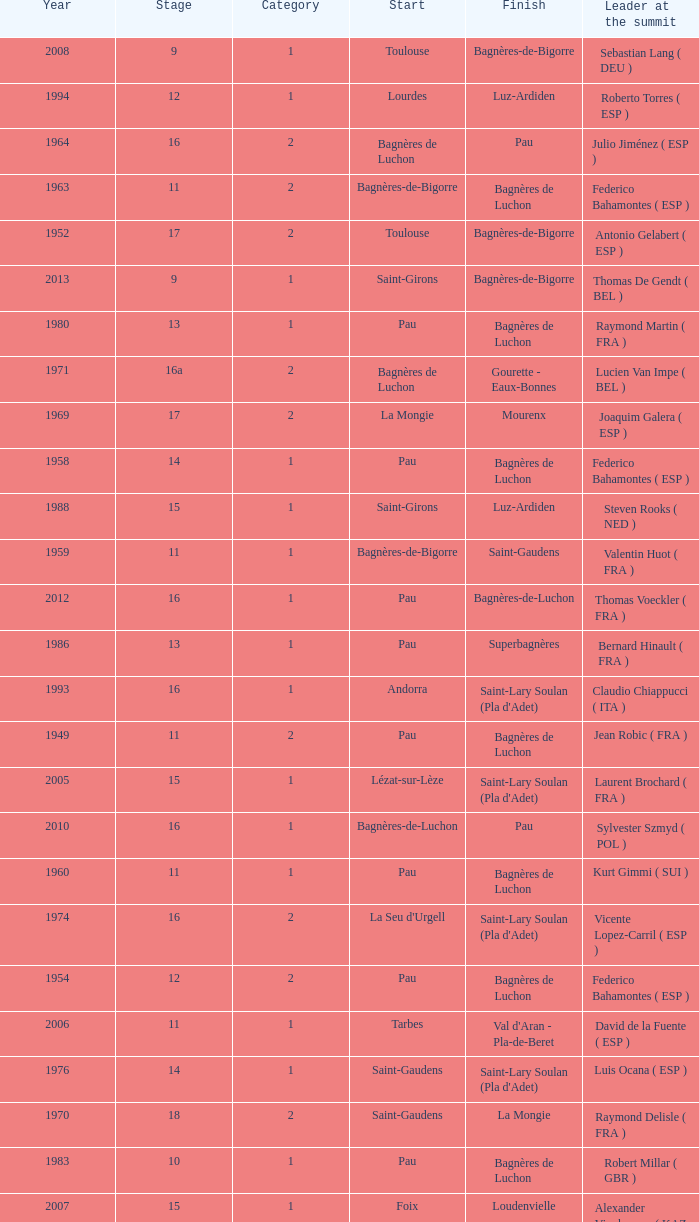What stage has a start of saint-girons in 1988? 15.0. I'm looking to parse the entire table for insights. Could you assist me with that? {'header': ['Year', 'Stage', 'Category', 'Start', 'Finish', 'Leader at the summit'], 'rows': [['2008', '9', '1', 'Toulouse', 'Bagnères-de-Bigorre', 'Sebastian Lang ( DEU )'], ['1994', '12', '1', 'Lourdes', 'Luz-Ardiden', 'Roberto Torres ( ESP )'], ['1964', '16', '2', 'Bagnères de Luchon', 'Pau', 'Julio Jiménez ( ESP )'], ['1963', '11', '2', 'Bagnères-de-Bigorre', 'Bagnères de Luchon', 'Federico Bahamontes ( ESP )'], ['1952', '17', '2', 'Toulouse', 'Bagnères-de-Bigorre', 'Antonio Gelabert ( ESP )'], ['2013', '9', '1', 'Saint-Girons', 'Bagnères-de-Bigorre', 'Thomas De Gendt ( BEL )'], ['1980', '13', '1', 'Pau', 'Bagnères de Luchon', 'Raymond Martin ( FRA )'], ['1971', '16a', '2', 'Bagnères de Luchon', 'Gourette - Eaux-Bonnes', 'Lucien Van Impe ( BEL )'], ['1969', '17', '2', 'La Mongie', 'Mourenx', 'Joaquim Galera ( ESP )'], ['1958', '14', '1', 'Pau', 'Bagnères de Luchon', 'Federico Bahamontes ( ESP )'], ['1988', '15', '1', 'Saint-Girons', 'Luz-Ardiden', 'Steven Rooks ( NED )'], ['1959', '11', '1', 'Bagnères-de-Bigorre', 'Saint-Gaudens', 'Valentin Huot ( FRA )'], ['2012', '16', '1', 'Pau', 'Bagnères-de-Luchon', 'Thomas Voeckler ( FRA )'], ['1986', '13', '1', 'Pau', 'Superbagnères', 'Bernard Hinault ( FRA )'], ['1993', '16', '1', 'Andorra', "Saint-Lary Soulan (Pla d'Adet)", 'Claudio Chiappucci ( ITA )'], ['1949', '11', '2', 'Pau', 'Bagnères de Luchon', 'Jean Robic ( FRA )'], ['2005', '15', '1', 'Lézat-sur-Lèze', "Saint-Lary Soulan (Pla d'Adet)", 'Laurent Brochard ( FRA )'], ['2010', '16', '1', 'Bagnères-de-Luchon', 'Pau', 'Sylvester Szmyd ( POL )'], ['1960', '11', '1', 'Pau', 'Bagnères de Luchon', 'Kurt Gimmi ( SUI )'], ['1974', '16', '2', "La Seu d'Urgell", "Saint-Lary Soulan (Pla d'Adet)", 'Vicente Lopez-Carril ( ESP )'], ['1954', '12', '2', 'Pau', 'Bagnères de Luchon', 'Federico Bahamontes ( ESP )'], ['2006', '11', '1', 'Tarbes', "Val d'Aran - Pla-de-Beret", 'David de la Fuente ( ESP )'], ['1976', '14', '1', 'Saint-Gaudens', "Saint-Lary Soulan (Pla d'Adet)", 'Luis Ocana ( ESP )'], ['1970', '18', '2', 'Saint-Gaudens', 'La Mongie', 'Raymond Delisle ( FRA )'], ['1983', '10', '1', 'Pau', 'Bagnères de Luchon', 'Robert Millar ( GBR )'], ['2007', '15', '1', 'Foix', 'Loudenvielle', 'Alexander Vinokourov ( KAZ )'], ['1961', '17', '2', 'Bagnères de Luchon', 'Pau', 'Imerio Massignan ( ITA )'], ['1951', '14', '2', 'Tarbes', 'Bagnères de Luchon', 'Fausto Coppi ( ITA )'], ['1995', '15', '1', 'Saint-Girons', 'Cauterets - Crêtes du Lys', 'Richard Virenque ( FRA )'], ['1981', '6', '1', 'Saint-Gaudens', "Saint-Lary Soulan (Pla d'Adet)", 'Bernard Hinault ( FRA )'], ['1953', '11', '2', 'Cauterets', 'Bagnères de Luchon', 'Jean Robic ( FRA )'], ['1989', '10', '1', 'Cauterets', 'Superbagnères', 'Robert Millar ( GBR )'], ['1956', '12', 'Not categorised', 'Pau', 'Bagnères de Luchon', 'Jean-Pierre Schmitz ( LUX )'], ['1955', '17', '2', 'Toulouse', 'Saint-Gaudens', 'Charly Gaul ( LUX )'], ['1999', '15', '1', 'Saint-Gaudens', 'Piau-Engaly', 'Alberto Elli ( ITA )'], ['1962', '12', '2', 'Pau', 'Saint-Gaudens', 'Federico Bahamontes ( ESP )'], ['1979', '3', '2', 'Bagnères de Luchon', 'Pau', 'Bernard Hinault ( FRA )'], ['2012', '17', 'Not categorised', 'Bagnères-de-Luchon', 'Peyragudes', 'Alejandro Valverde ( ESP )'], ['1972', '8', '2', 'Pau', 'Bagnères de Luchon', 'Lucien Van Impe ( BEL )'], ['2001', '13', '1', 'Foix', "Saint-Lary Soulan (Pla d'Adet)", 'Laurent Jalabert ( FRA )'], ['1948', '8', '2', 'Lourdes', 'Toulouse', 'Jean Robic ( FRA )'], ['2003', '14', '1', 'Saint-Girons', 'Loudenvielle', 'Gilberto Simoni ( ITA )'], ['1947', '15', '1', 'Bagnères de Luchon', 'Pau', 'Jean Robic ( FRA )'], ['1998', '10', '1', 'Pau', 'Bagnères de Luchon', 'Rodolfo Massi ( ITA )']]} 